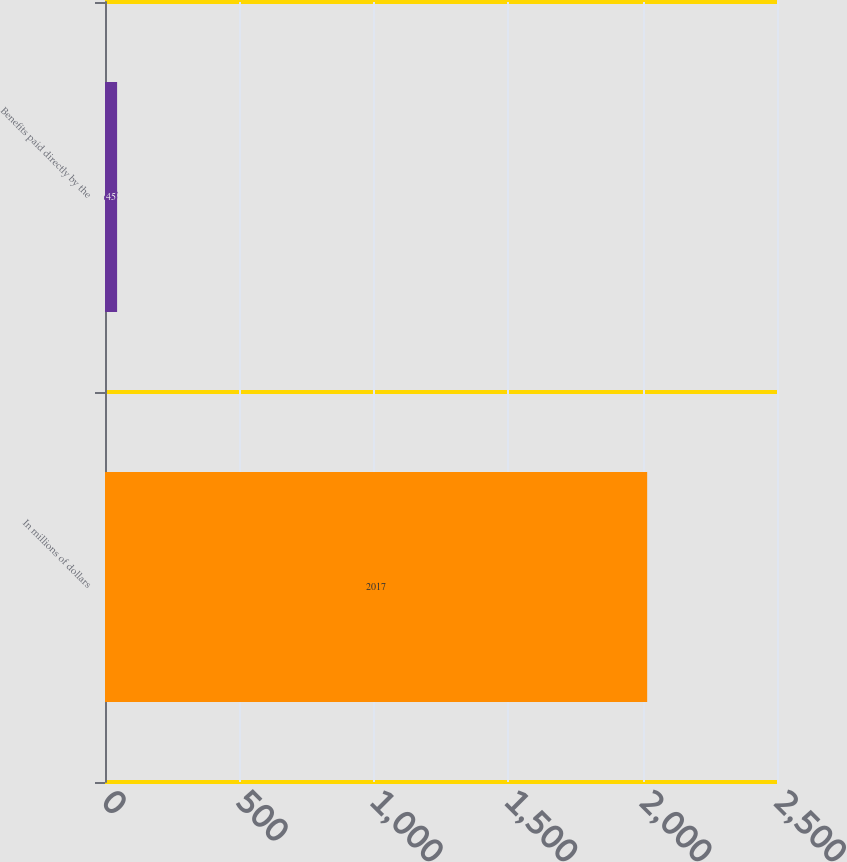Convert chart to OTSL. <chart><loc_0><loc_0><loc_500><loc_500><bar_chart><fcel>In millions of dollars<fcel>Benefits paid directly by the<nl><fcel>2017<fcel>45<nl></chart> 